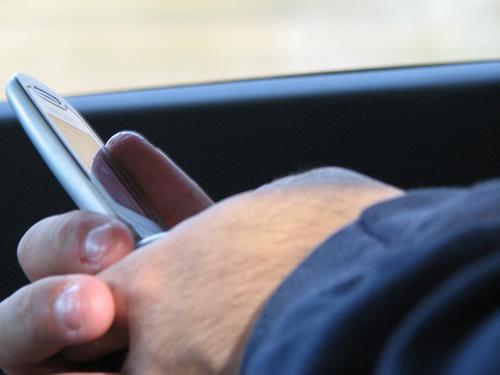How many phones are there?
Give a very brief answer. 1. 